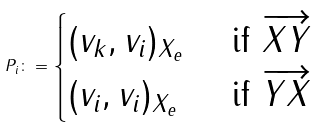<formula> <loc_0><loc_0><loc_500><loc_500>P _ { i } \colon = \begin{cases} ( v _ { k } , v _ { i } ) _ { X _ { e } } & \text { if } \overrightarrow { X Y } \\ ( v _ { i } , v _ { i } ) _ { X _ { e } } & \text { if } \overrightarrow { Y X } \\ \end{cases}</formula> 